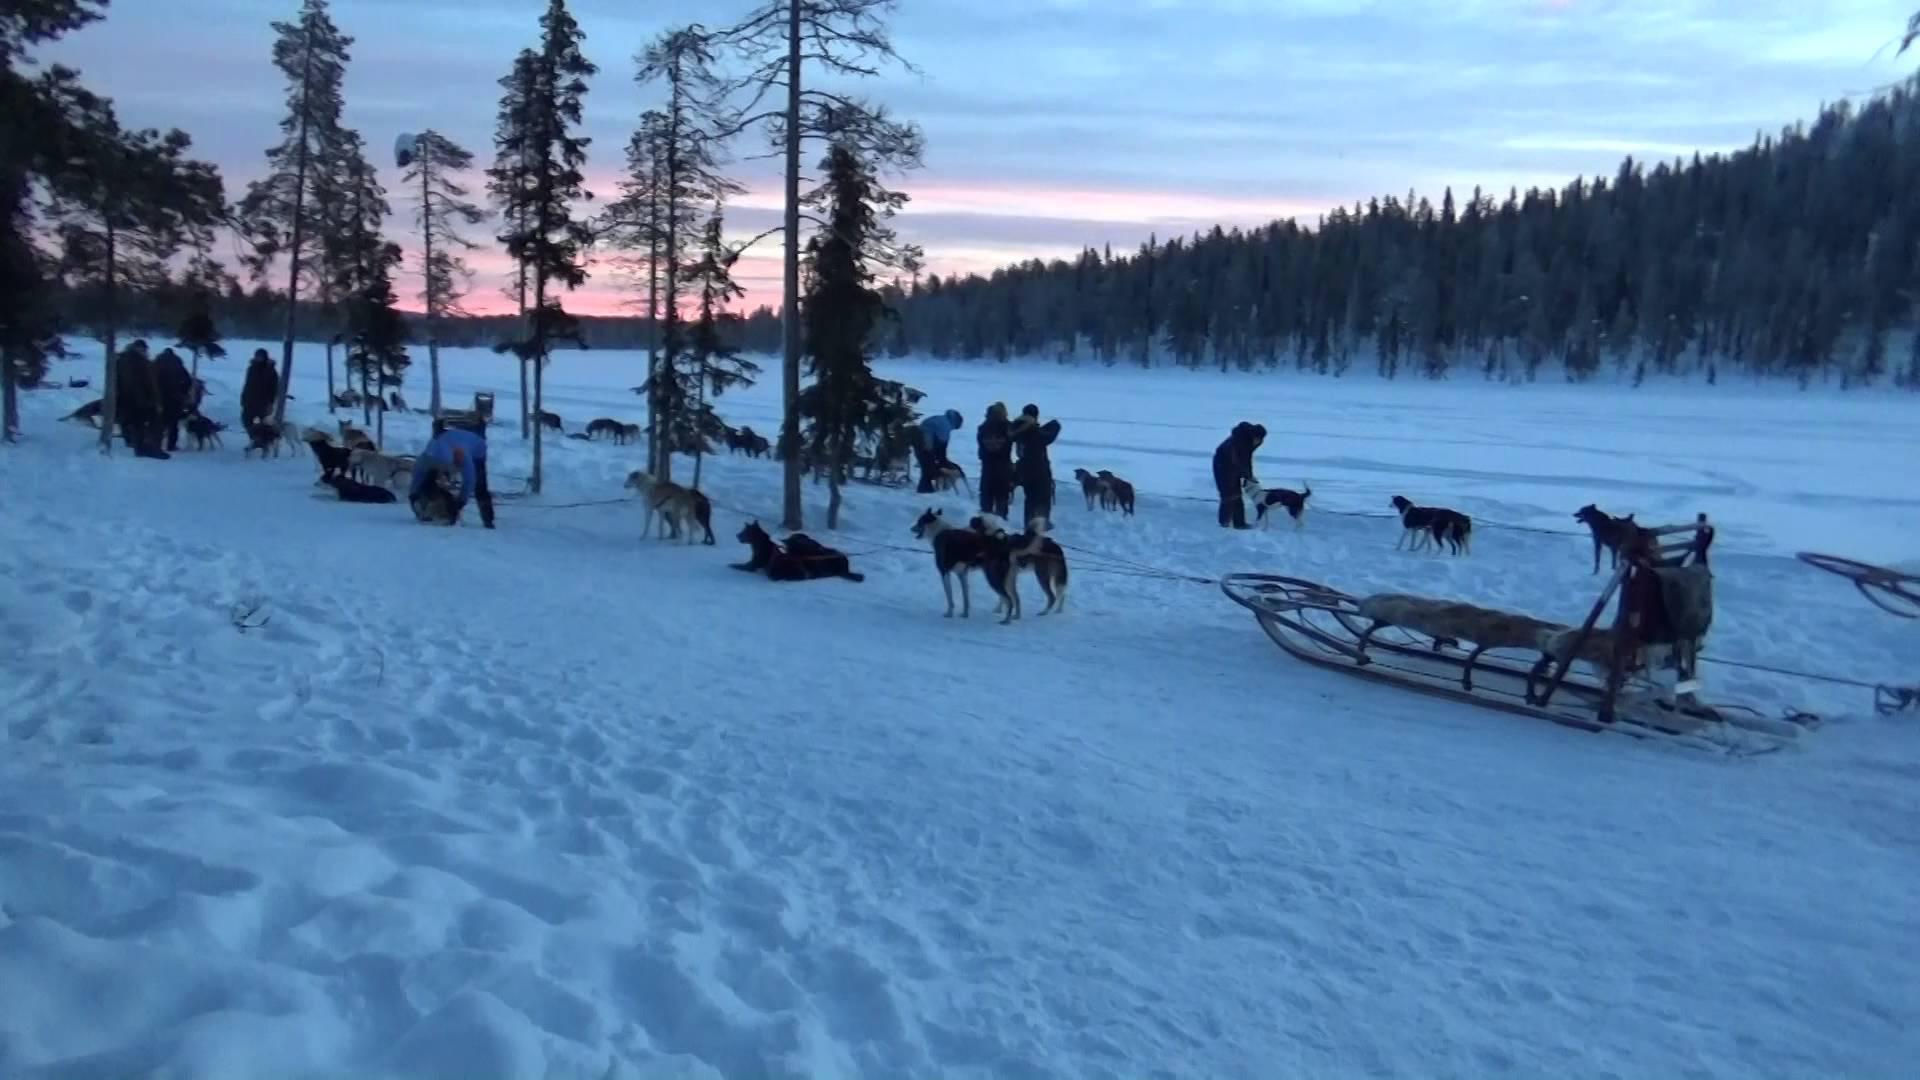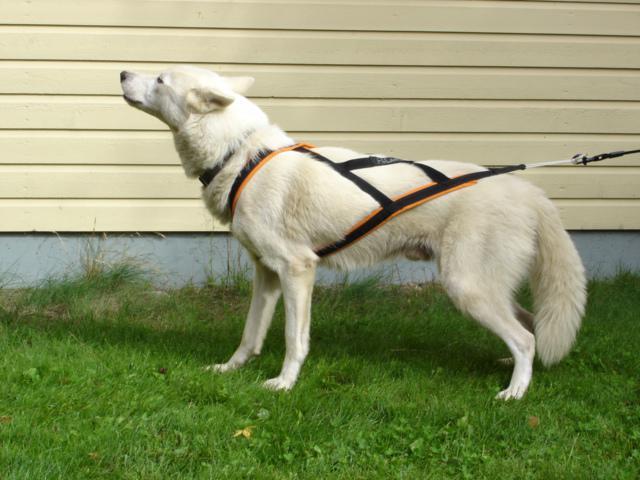The first image is the image on the left, the second image is the image on the right. For the images displayed, is the sentence "One photo contains a single dog." factually correct? Answer yes or no. Yes. The first image is the image on the left, the second image is the image on the right. Given the left and right images, does the statement "An image shows just one dog, which is wearing a harness." hold true? Answer yes or no. Yes. 